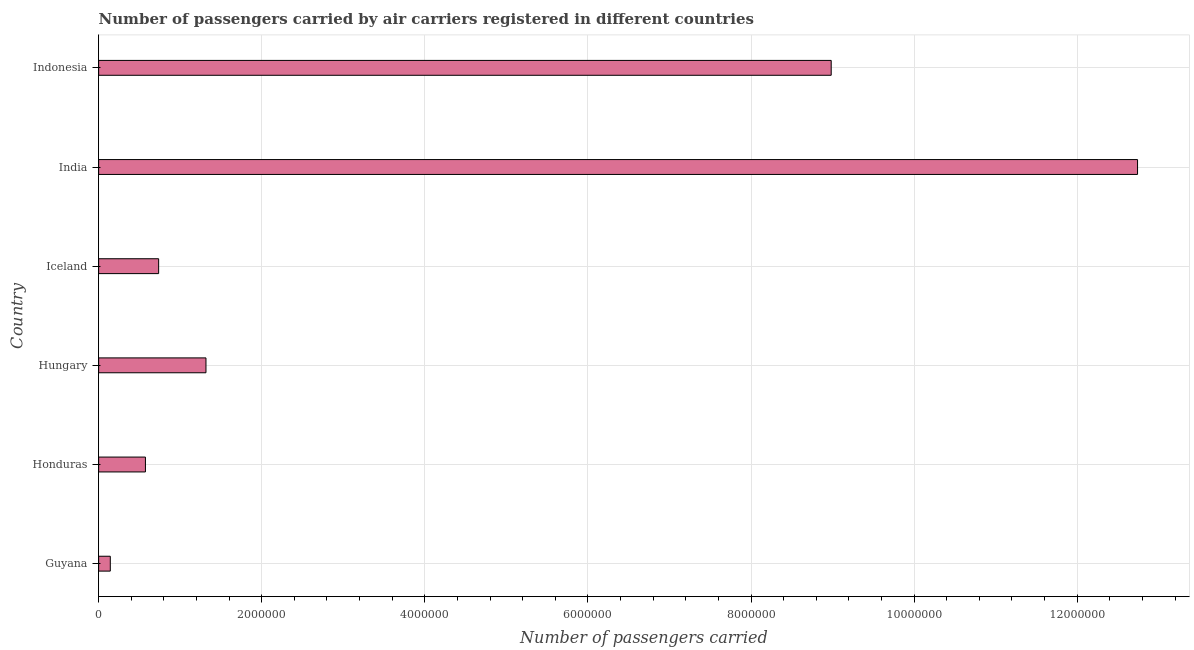Does the graph contain grids?
Ensure brevity in your answer.  Yes. What is the title of the graph?
Provide a succinct answer. Number of passengers carried by air carriers registered in different countries. What is the label or title of the X-axis?
Provide a succinct answer. Number of passengers carried. What is the number of passengers carried in Guyana?
Provide a succinct answer. 1.43e+05. Across all countries, what is the maximum number of passengers carried?
Provide a succinct answer. 1.27e+07. Across all countries, what is the minimum number of passengers carried?
Give a very brief answer. 1.43e+05. In which country was the number of passengers carried minimum?
Your answer should be compact. Guyana. What is the sum of the number of passengers carried?
Your response must be concise. 2.45e+07. What is the difference between the number of passengers carried in India and Indonesia?
Give a very brief answer. 3.76e+06. What is the average number of passengers carried per country?
Your response must be concise. 4.08e+06. What is the median number of passengers carried?
Ensure brevity in your answer.  1.03e+06. In how many countries, is the number of passengers carried greater than 2400000 ?
Give a very brief answer. 2. What is the ratio of the number of passengers carried in Hungary to that in Indonesia?
Ensure brevity in your answer.  0.15. Is the difference between the number of passengers carried in Hungary and India greater than the difference between any two countries?
Provide a succinct answer. No. What is the difference between the highest and the second highest number of passengers carried?
Your answer should be compact. 3.76e+06. What is the difference between the highest and the lowest number of passengers carried?
Your answer should be compact. 1.26e+07. In how many countries, is the number of passengers carried greater than the average number of passengers carried taken over all countries?
Make the answer very short. 2. How many bars are there?
Provide a succinct answer. 6. Are all the bars in the graph horizontal?
Offer a terse response. Yes. What is the difference between two consecutive major ticks on the X-axis?
Make the answer very short. 2.00e+06. What is the Number of passengers carried of Guyana?
Keep it short and to the point. 1.43e+05. What is the Number of passengers carried in Honduras?
Give a very brief answer. 5.74e+05. What is the Number of passengers carried of Hungary?
Offer a terse response. 1.32e+06. What is the Number of passengers carried of Iceland?
Offer a very short reply. 7.36e+05. What is the Number of passengers carried of India?
Provide a succinct answer. 1.27e+07. What is the Number of passengers carried in Indonesia?
Your answer should be compact. 8.98e+06. What is the difference between the Number of passengers carried in Guyana and Honduras?
Keep it short and to the point. -4.31e+05. What is the difference between the Number of passengers carried in Guyana and Hungary?
Provide a succinct answer. -1.17e+06. What is the difference between the Number of passengers carried in Guyana and Iceland?
Your answer should be very brief. -5.93e+05. What is the difference between the Number of passengers carried in Guyana and India?
Provide a succinct answer. -1.26e+07. What is the difference between the Number of passengers carried in Guyana and Indonesia?
Give a very brief answer. -8.84e+06. What is the difference between the Number of passengers carried in Honduras and Hungary?
Your answer should be compact. -7.42e+05. What is the difference between the Number of passengers carried in Honduras and Iceland?
Your answer should be compact. -1.62e+05. What is the difference between the Number of passengers carried in Honduras and India?
Offer a very short reply. -1.22e+07. What is the difference between the Number of passengers carried in Honduras and Indonesia?
Your answer should be compact. -8.41e+06. What is the difference between the Number of passengers carried in Hungary and Iceland?
Give a very brief answer. 5.80e+05. What is the difference between the Number of passengers carried in Hungary and India?
Ensure brevity in your answer.  -1.14e+07. What is the difference between the Number of passengers carried in Hungary and Indonesia?
Your answer should be compact. -7.67e+06. What is the difference between the Number of passengers carried in Iceland and India?
Make the answer very short. -1.20e+07. What is the difference between the Number of passengers carried in Iceland and Indonesia?
Make the answer very short. -8.25e+06. What is the difference between the Number of passengers carried in India and Indonesia?
Offer a very short reply. 3.76e+06. What is the ratio of the Number of passengers carried in Guyana to that in Honduras?
Offer a very short reply. 0.25. What is the ratio of the Number of passengers carried in Guyana to that in Hungary?
Your answer should be very brief. 0.11. What is the ratio of the Number of passengers carried in Guyana to that in Iceland?
Your answer should be very brief. 0.19. What is the ratio of the Number of passengers carried in Guyana to that in India?
Provide a short and direct response. 0.01. What is the ratio of the Number of passengers carried in Guyana to that in Indonesia?
Provide a short and direct response. 0.02. What is the ratio of the Number of passengers carried in Honduras to that in Hungary?
Your response must be concise. 0.44. What is the ratio of the Number of passengers carried in Honduras to that in Iceland?
Offer a terse response. 0.78. What is the ratio of the Number of passengers carried in Honduras to that in India?
Provide a short and direct response. 0.04. What is the ratio of the Number of passengers carried in Honduras to that in Indonesia?
Your answer should be compact. 0.06. What is the ratio of the Number of passengers carried in Hungary to that in Iceland?
Ensure brevity in your answer.  1.79. What is the ratio of the Number of passengers carried in Hungary to that in India?
Provide a succinct answer. 0.1. What is the ratio of the Number of passengers carried in Hungary to that in Indonesia?
Provide a succinct answer. 0.15. What is the ratio of the Number of passengers carried in Iceland to that in India?
Keep it short and to the point. 0.06. What is the ratio of the Number of passengers carried in Iceland to that in Indonesia?
Make the answer very short. 0.08. What is the ratio of the Number of passengers carried in India to that in Indonesia?
Offer a terse response. 1.42. 